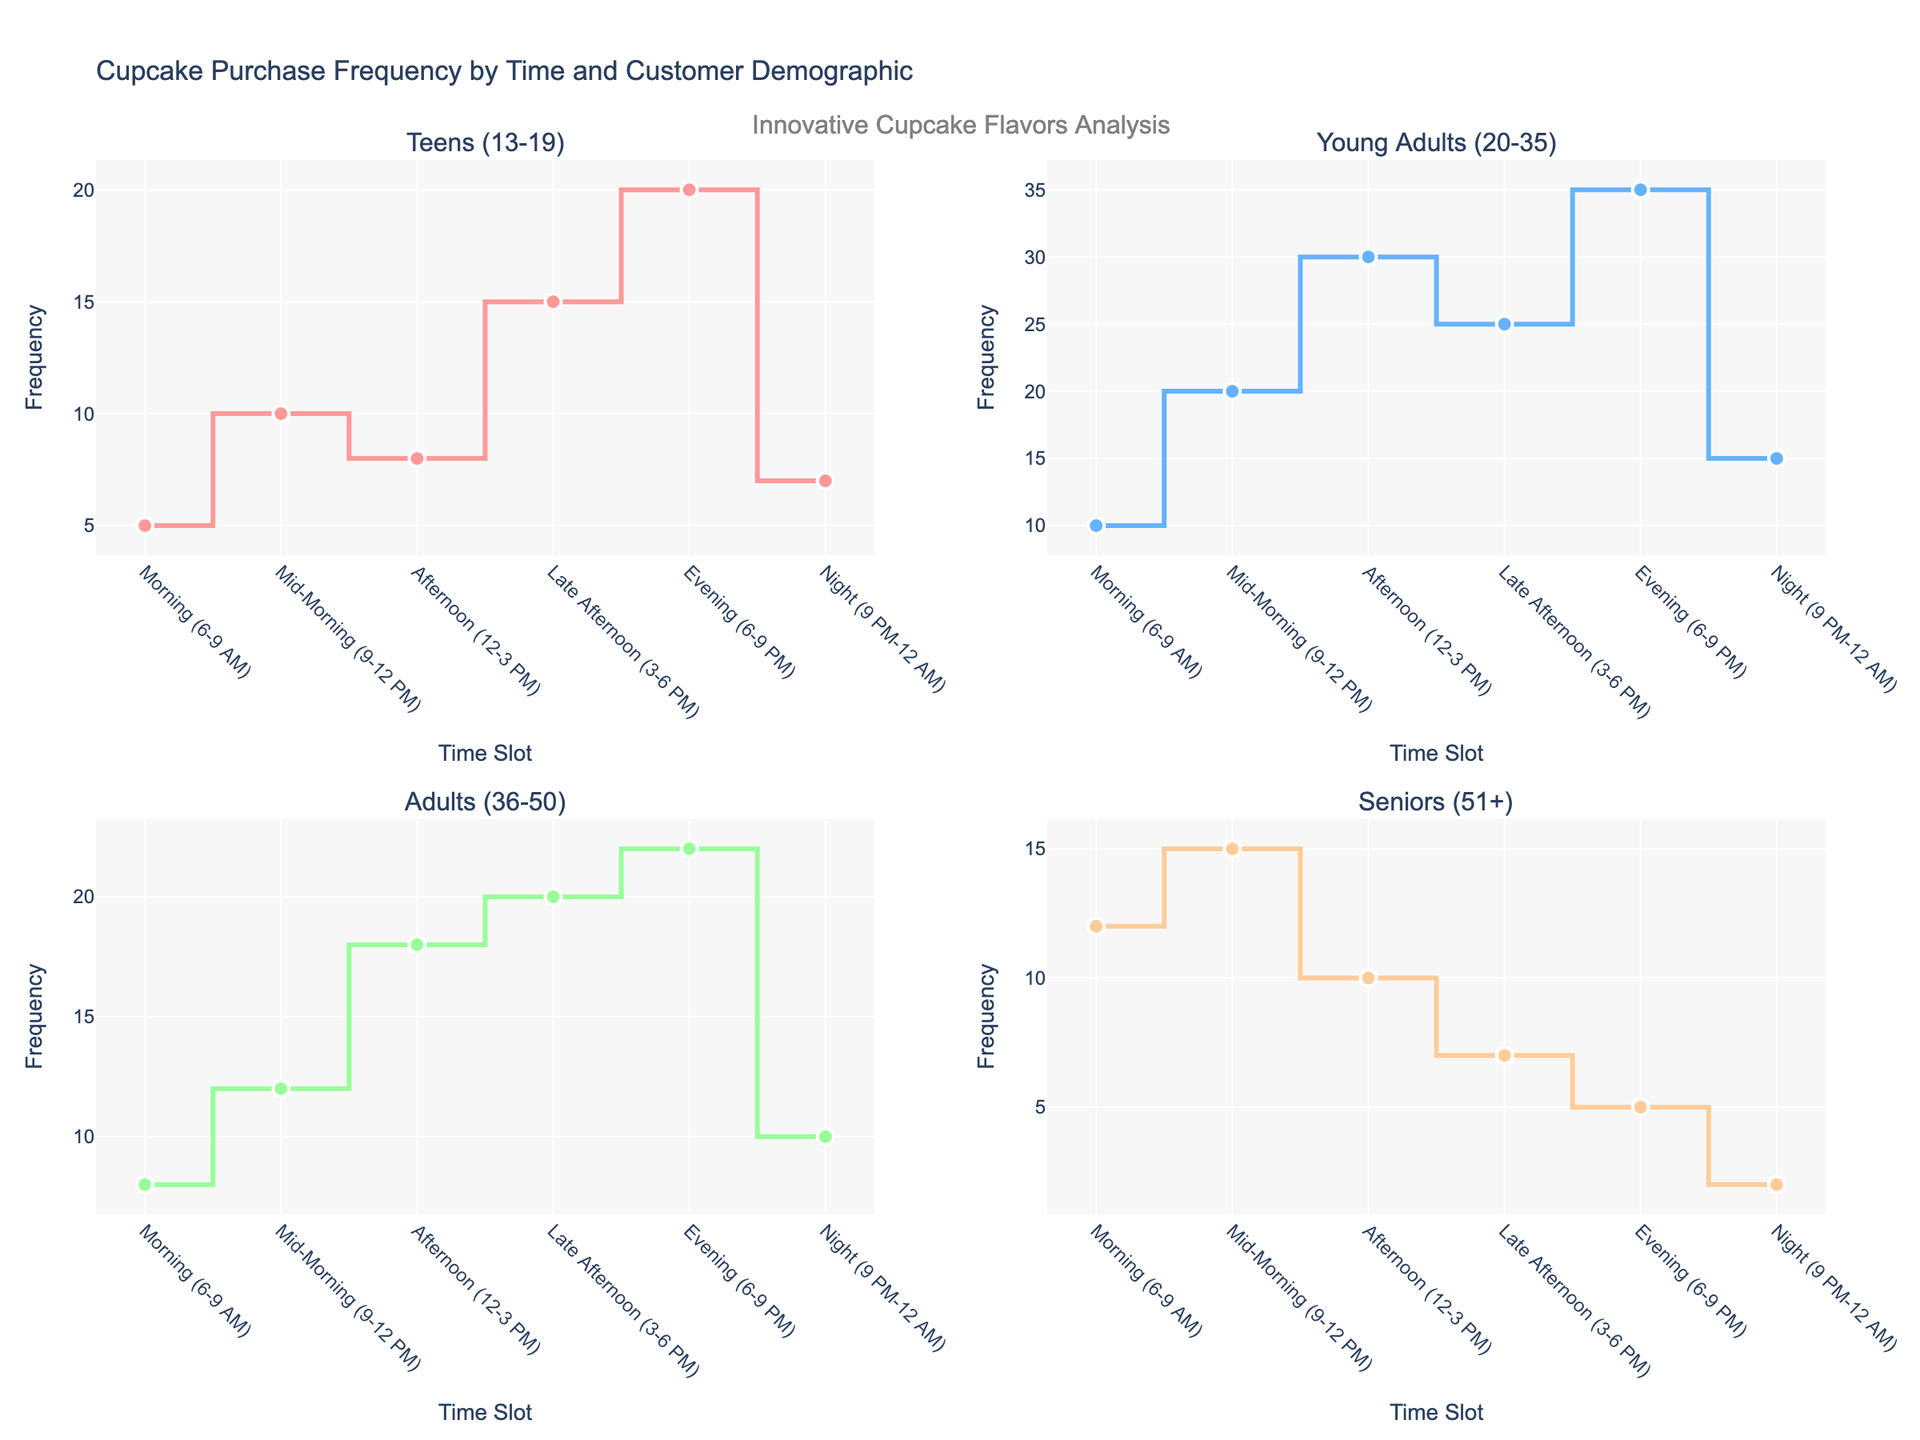What is the highest frequency of cupcake purchases among Teens (13-19) throughout the day? The highest frequency for Teens (13-19) is observed at the Evening time slot (6-9 PM). By looking at the corresponding stair plot for the Teens demographic, the tallest stair step occurs during the Evening period.
Answer: 20 Which demographic group has the lowest frequency of cupcake purchases during the Night (9 PM-12 AM)? By examining the stair plots for all four demographic groups during the Night time slot, we can observe that the lowest frequency is seen in the Seniors (51+) demographic, indicated by the shortest bar.
Answer: Seniors (51+) At what time slot do Young Adults (20-35) have the highest frequency of cupcake purchases? By examining the stair plot for Young Adults (20-35), the tallest step corresponds to the Evening time slot (6-9 PM).
Answer: Evening (6-9 PM) How does the frequency of cupcake purchases in the Afternoon (12-3 PM) compare between Teens (13-19) and Adults (36-50)? To compare, examine the Afternoon step in both demographics' stair plots. Teens have a frequency of 8 while Adults have a frequency of 18. Adults have a higher purchase frequency in the Afternoon compared to Teens.
Answer: Adults (36-50) have a higher frequency What is the average frequency of cupcake purchases for all time slots for Seniors (51+)? Calculate the total frequency for Seniors (51+): 12 (Morning) + 15 (Mid-Morning) + 10 (Afternoon) + 7 (Late Afternoon) + 5 (Evening) + 2 (Night) = 51. Divide by the number of time slots (6): 51/6 ≈ 8.5.
Answer: 8.5 Which time slot has the highest combined frequency of cupcake purchases across all demographics? Sum up the frequencies for each time slot across all demographics: 
- Morning: 5 (Teens) + 10 (Young Adults) + 8 (Adults) + 12 (Seniors) = 35
- Mid-Morning: 10 + 20 + 12 + 15 = 57
- Afternoon: 8 + 30 + 18 + 10 = 66
- Late Afternoon: 15 + 25 + 20 + 7 = 67
- Evening: 20 + 35 + 22 + 5 = 82
- Night: 7 + 15 + 10 + 2 = 34
The Evening time slot has the highest combined frequency (82).
Answer: Evening (6-9 PM) What is the combined frequency of cupcake purchases for Adults (36-50) during the Morning (6-9 AM) and Mid-Morning (9-12 PM)? Add the frequencies for the two time slots: Morning (8) + Mid-Morning (12) = 20.
Answer: 20 